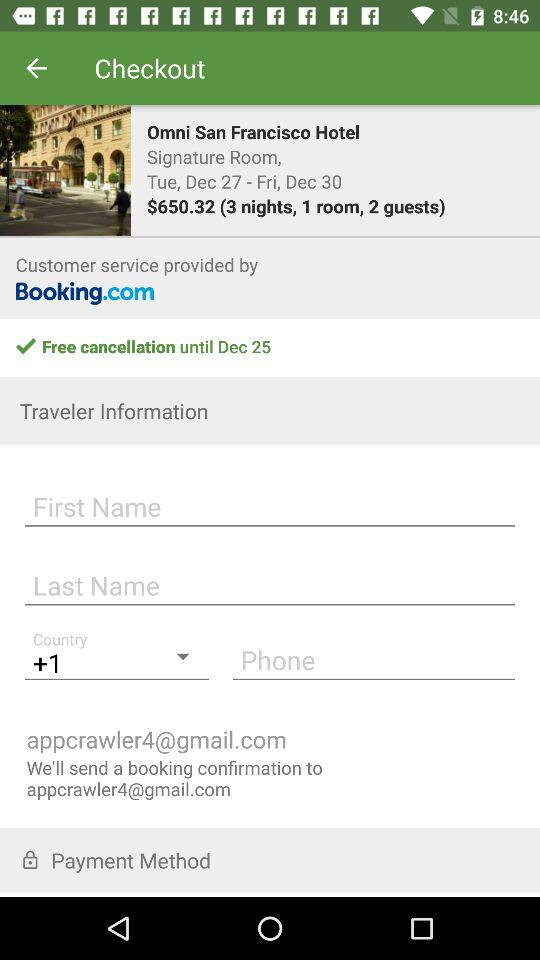What is the hotel name? The hotel name is Omni San Francisco Hotel. 